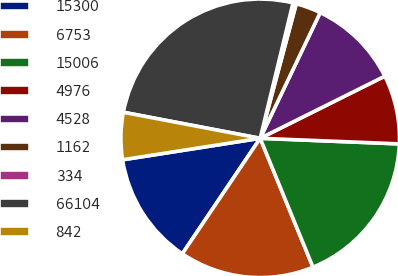Convert chart to OTSL. <chart><loc_0><loc_0><loc_500><loc_500><pie_chart><fcel>15300<fcel>6753<fcel>15006<fcel>4976<fcel>4528<fcel>1162<fcel>334<fcel>66104<fcel>842<nl><fcel>13.09%<fcel>15.63%<fcel>18.17%<fcel>8.0%<fcel>10.55%<fcel>2.92%<fcel>0.38%<fcel>25.79%<fcel>5.46%<nl></chart> 